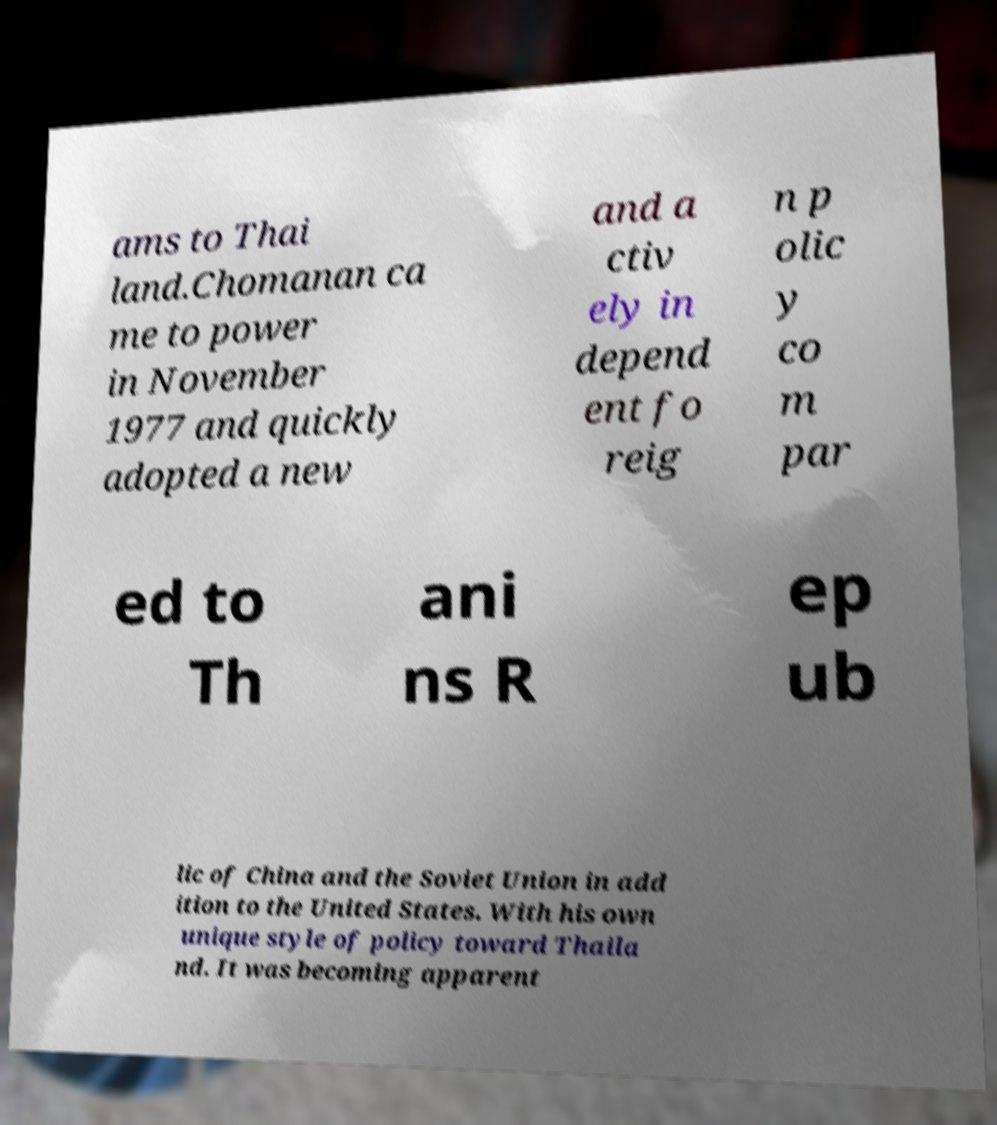For documentation purposes, I need the text within this image transcribed. Could you provide that? ams to Thai land.Chomanan ca me to power in November 1977 and quickly adopted a new and a ctiv ely in depend ent fo reig n p olic y co m par ed to Th ani ns R ep ub lic of China and the Soviet Union in add ition to the United States. With his own unique style of policy toward Thaila nd. It was becoming apparent 